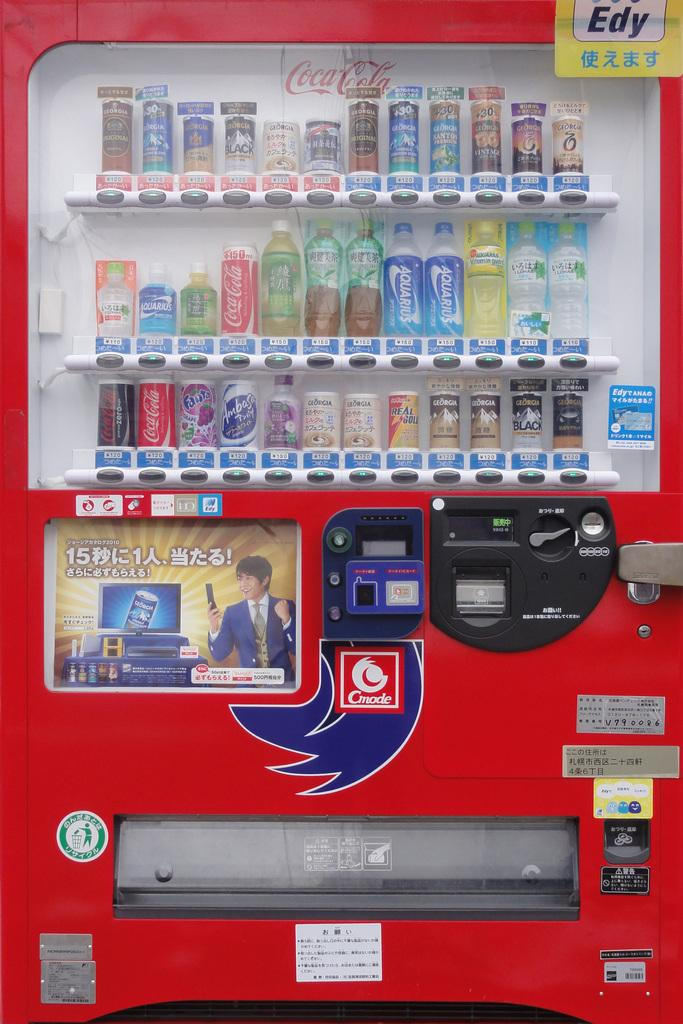<image>
Summarize the visual content of the image. a drink machine that has the coca-cola logo in the background 